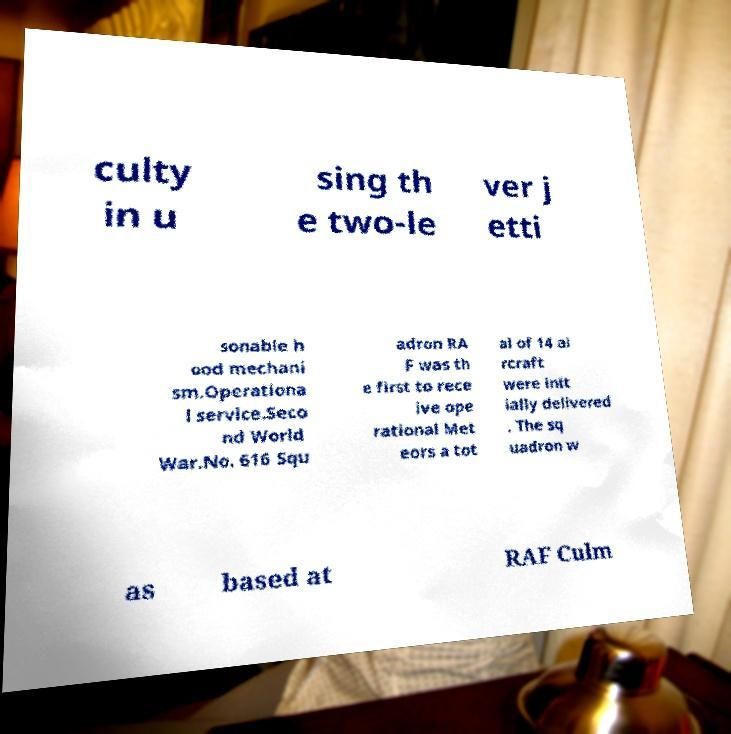Could you assist in decoding the text presented in this image and type it out clearly? culty in u sing th e two-le ver j etti sonable h ood mechani sm.Operationa l service.Seco nd World War.No. 616 Squ adron RA F was th e first to rece ive ope rational Met eors a tot al of 14 ai rcraft were init ially delivered . The sq uadron w as based at RAF Culm 